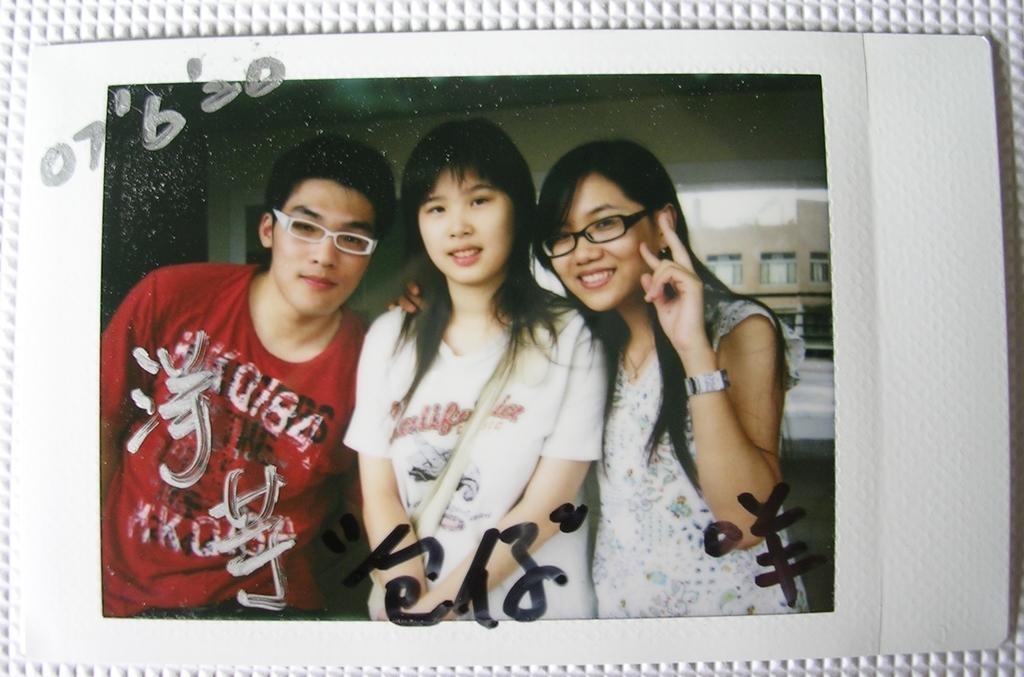In one or two sentences, can you explain what this image depicts? In the center of the image there is a photograph. In the photograph we can see three people standing. In the background there are buildings. 